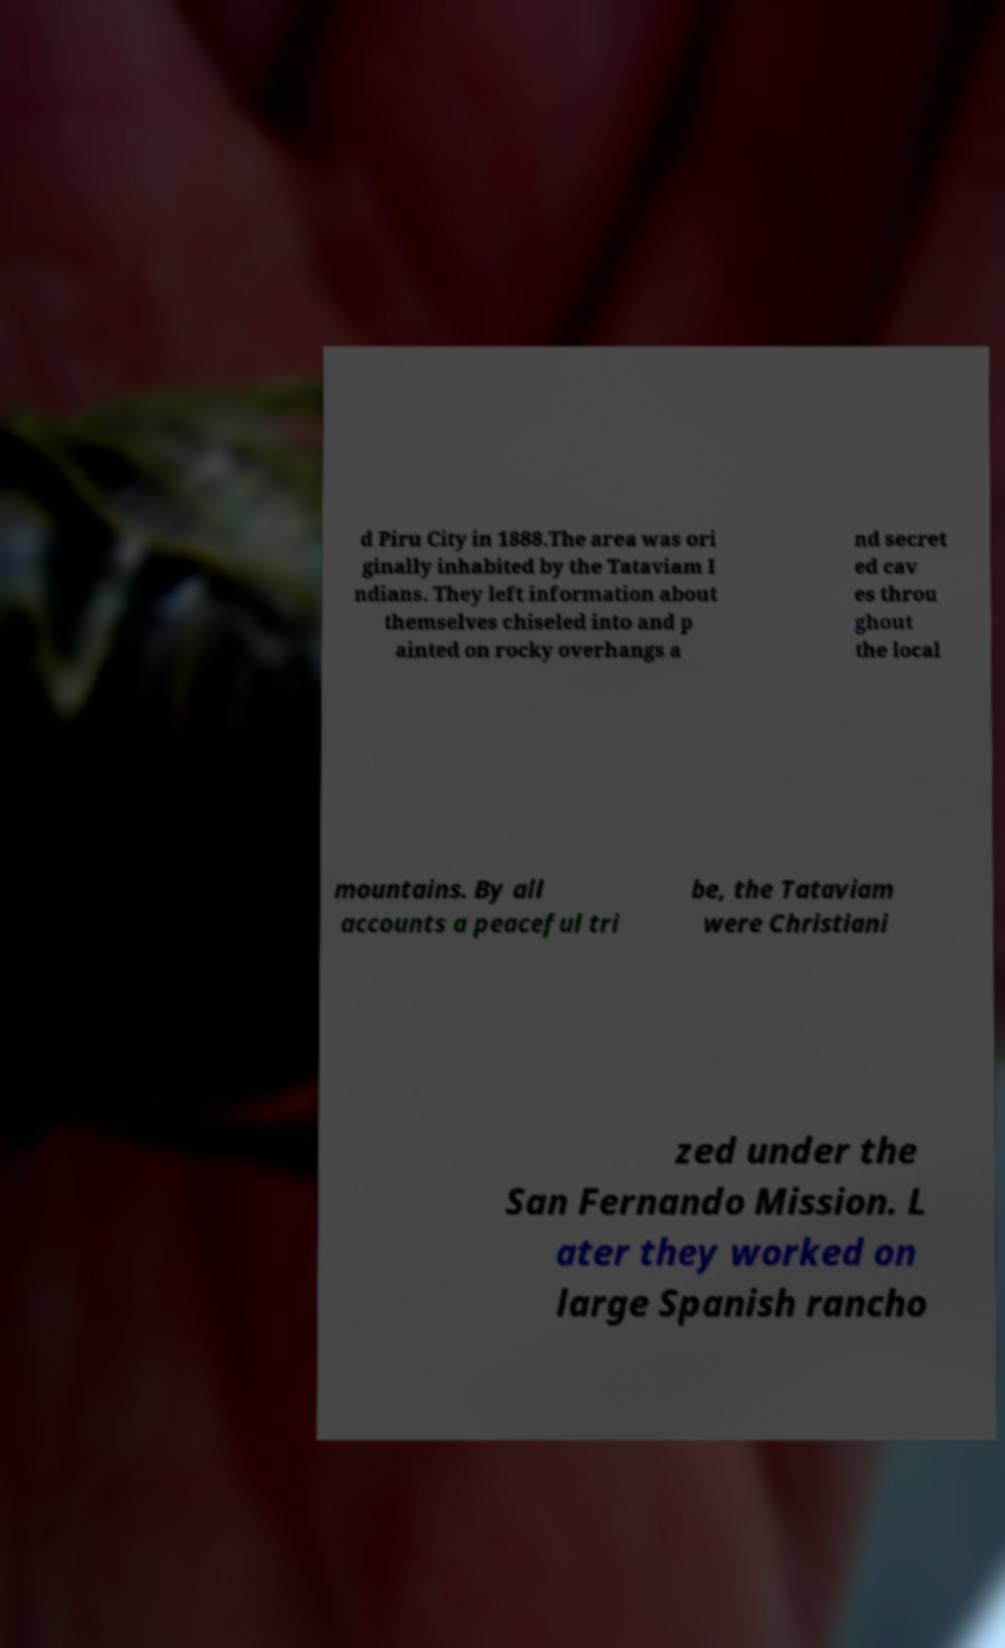What messages or text are displayed in this image? I need them in a readable, typed format. d Piru City in 1888.The area was ori ginally inhabited by the Tataviam I ndians. They left information about themselves chiseled into and p ainted on rocky overhangs a nd secret ed cav es throu ghout the local mountains. By all accounts a peaceful tri be, the Tataviam were Christiani zed under the San Fernando Mission. L ater they worked on large Spanish rancho 